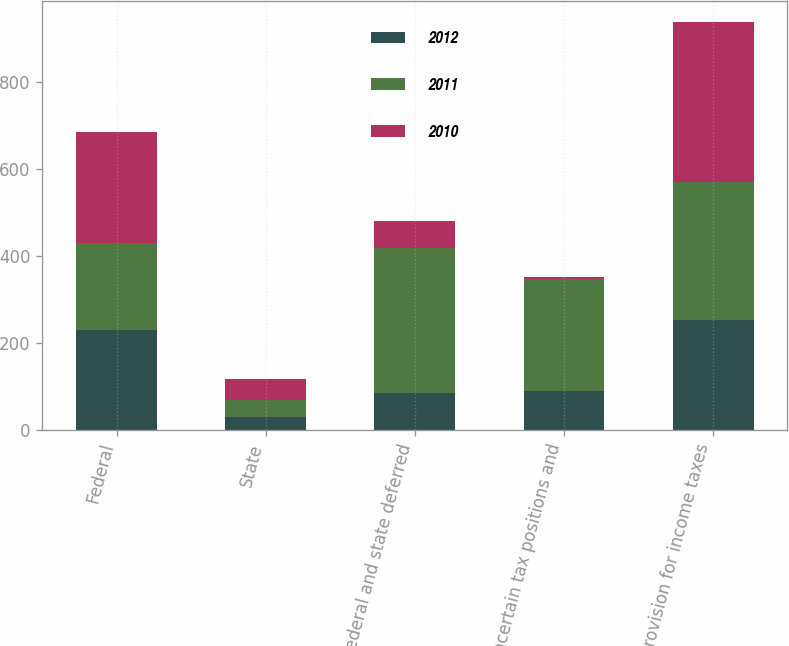Convert chart to OTSL. <chart><loc_0><loc_0><loc_500><loc_500><stacked_bar_chart><ecel><fcel>Federal<fcel>State<fcel>Federal and state deferred<fcel>Uncertain tax positions and<fcel>Provision for income taxes<nl><fcel>2012<fcel>228.7<fcel>29.2<fcel>83.9<fcel>90<fcel>251.8<nl><fcel>2011<fcel>201.7<fcel>38.6<fcel>334.8<fcel>257.7<fcel>317.4<nl><fcel>2010<fcel>253.9<fcel>50.2<fcel>61.4<fcel>4<fcel>369.5<nl></chart> 